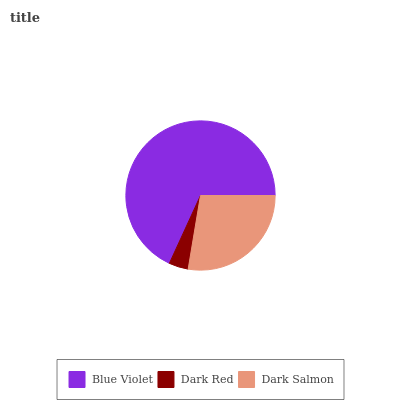Is Dark Red the minimum?
Answer yes or no. Yes. Is Blue Violet the maximum?
Answer yes or no. Yes. Is Dark Salmon the minimum?
Answer yes or no. No. Is Dark Salmon the maximum?
Answer yes or no. No. Is Dark Salmon greater than Dark Red?
Answer yes or no. Yes. Is Dark Red less than Dark Salmon?
Answer yes or no. Yes. Is Dark Red greater than Dark Salmon?
Answer yes or no. No. Is Dark Salmon less than Dark Red?
Answer yes or no. No. Is Dark Salmon the high median?
Answer yes or no. Yes. Is Dark Salmon the low median?
Answer yes or no. Yes. Is Blue Violet the high median?
Answer yes or no. No. Is Dark Red the low median?
Answer yes or no. No. 